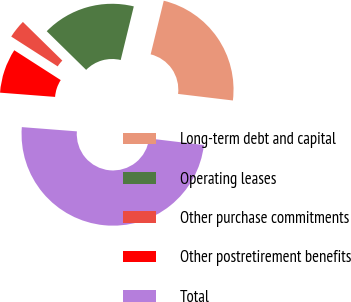Convert chart to OTSL. <chart><loc_0><loc_0><loc_500><loc_500><pie_chart><fcel>Long-term debt and capital<fcel>Operating leases<fcel>Other purchase commitments<fcel>Other postretirement benefits<fcel>Total<nl><fcel>23.08%<fcel>16.47%<fcel>3.26%<fcel>7.86%<fcel>49.33%<nl></chart> 